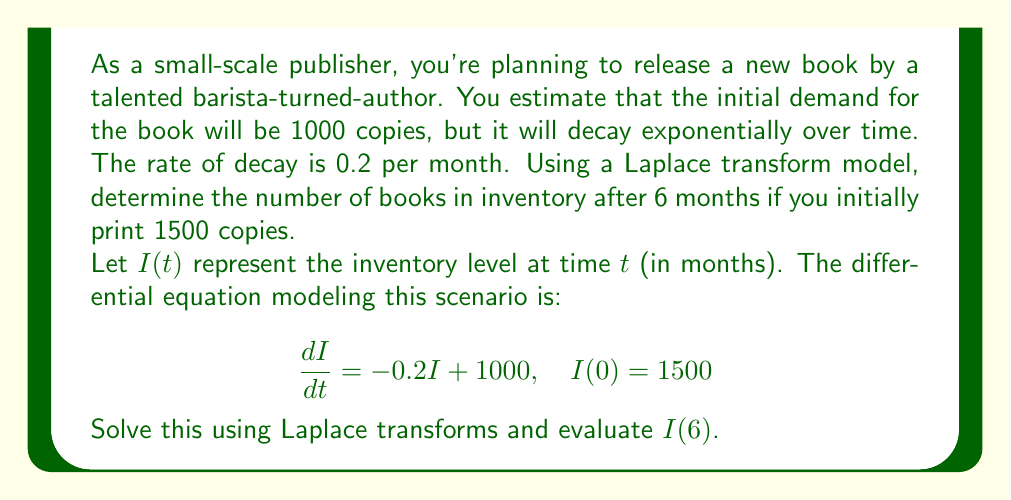What is the answer to this math problem? Let's solve this step-by-step using Laplace transforms:

1) Take the Laplace transform of both sides of the differential equation:
   $$\mathcal{L}\{\frac{dI}{dt}\} = \mathcal{L}\{-0.2I + 1000\}$$

2) Using Laplace transform properties:
   $$s\mathcal{L}\{I\} - I(0) = -0.2\mathcal{L}\{I\} + \frac{1000}{s}$$

3) Let $\mathcal{L}\{I\} = X(s)$. Substituting $I(0) = 1500$:
   $$sX(s) - 1500 = -0.2X(s) + \frac{1000}{s}$$

4) Rearranging terms:
   $$(s + 0.2)X(s) = 1500 + \frac{1000}{s}$$

5) Solving for $X(s)$:
   $$X(s) = \frac{1500}{s + 0.2} + \frac{1000}{s(s + 0.2)}$$

6) Decomposing into partial fractions:
   $$X(s) = \frac{1500}{s + 0.2} + \frac{5000}{s} - \frac{5000}{s + 0.2}$$

7) Taking the inverse Laplace transform:
   $$I(t) = 1500e^{-0.2t} + 5000 - 5000e^{-0.2t}$$

8) Simplifying:
   $$I(t) = 5000 - 3500e^{-0.2t}$$

9) Evaluating at $t = 6$:
   $$I(6) = 5000 - 3500e^{-0.2(6)} \approx 2764.66$$
Answer: $2765$ books (rounded to the nearest whole number) 